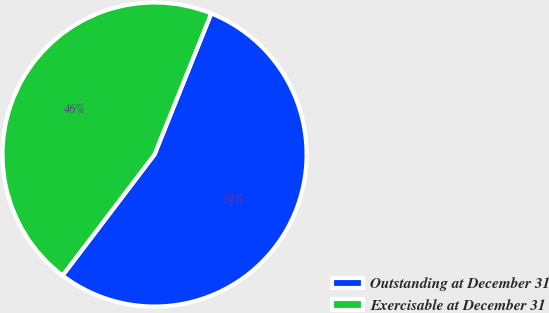<chart> <loc_0><loc_0><loc_500><loc_500><pie_chart><fcel>Outstanding at December 31<fcel>Exercisable at December 31<nl><fcel>54.26%<fcel>45.74%<nl></chart> 